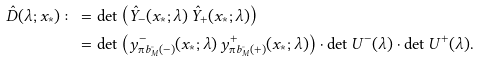<formula> <loc_0><loc_0><loc_500><loc_500>\hat { D } ( \lambda ; x _ { \ast } ) \colon = & \, \det \left ( \hat { Y } _ { - } ( x _ { \ast } ; \lambda ) \, \hat { Y } _ { + } ( x _ { \ast } ; \lambda ) \right ) \\ = & \, \det \left ( y _ { \i b ^ { \circ } _ { M } ( - ) } ^ { - } ( x _ { \ast } ; \lambda ) \, y _ { \i b ^ { \circ } _ { M } ( + ) } ^ { + } ( x _ { \ast } ; \lambda ) \right ) \cdot \det U ^ { - } ( \lambda ) \cdot \det U ^ { + } ( \lambda ) .</formula> 